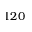Convert formula to latex. <formula><loc_0><loc_0><loc_500><loc_500>1 2 0</formula> 